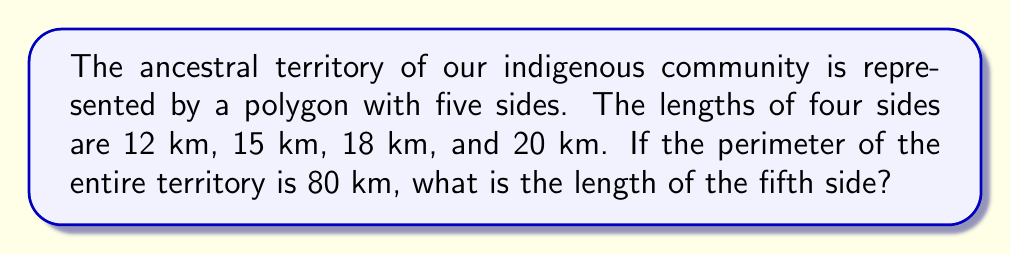What is the answer to this math problem? To solve this problem, we'll follow these steps:

1. Understand the given information:
   - The territory is a pentagon (5-sided polygon)
   - Four known sides: 12 km, 15 km, 18 km, and 20 km
   - Total perimeter: 80 km

2. Calculate the sum of the known sides:
   $12 + 15 + 18 + 20 = 65$ km

3. Use the formula for perimeter:
   Perimeter = sum of all sides
   $80 = 65 + x$, where $x$ is the length of the unknown side

4. Solve for $x$:
   $x = 80 - 65 = 15$ km

Therefore, the length of the fifth side of our ancestral territory is 15 km.

[asy]
unitsize(0.1cm);
pair A = (0,0);
pair B = (50,0);
pair C = (70,30);
pair D = (35,50);
pair E = (-10,35);

draw(A--B--C--D--E--A);

label("12 km", (B+C)/2, E);
label("15 km", (C+D)/2, NW);
label("18 km", (D+E)/2, NW);
label("20 km", (E+A)/2, SW);
label("15 km", (A+B)/2, S);

dot("A", A, SW);
dot("B", B, SE);
dot("C", C, E);
dot("D", D, N);
dot("E", E, W);
[/asy]
Answer: 15 km 